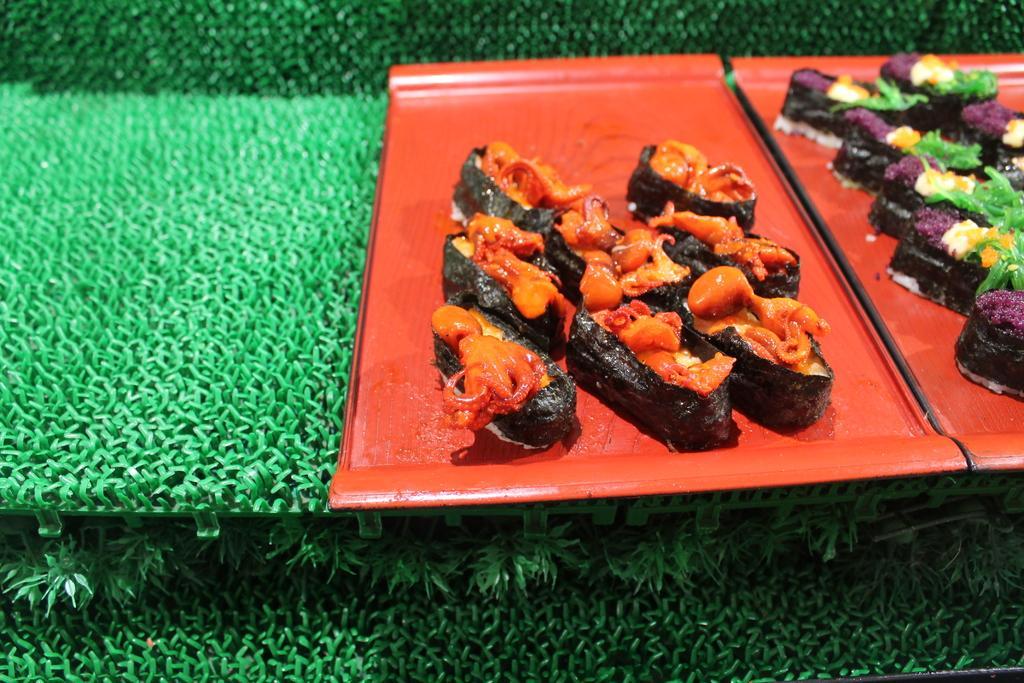How would you summarize this image in a sentence or two? In this image there are food items placed on two trays, which is on the green color mat. 